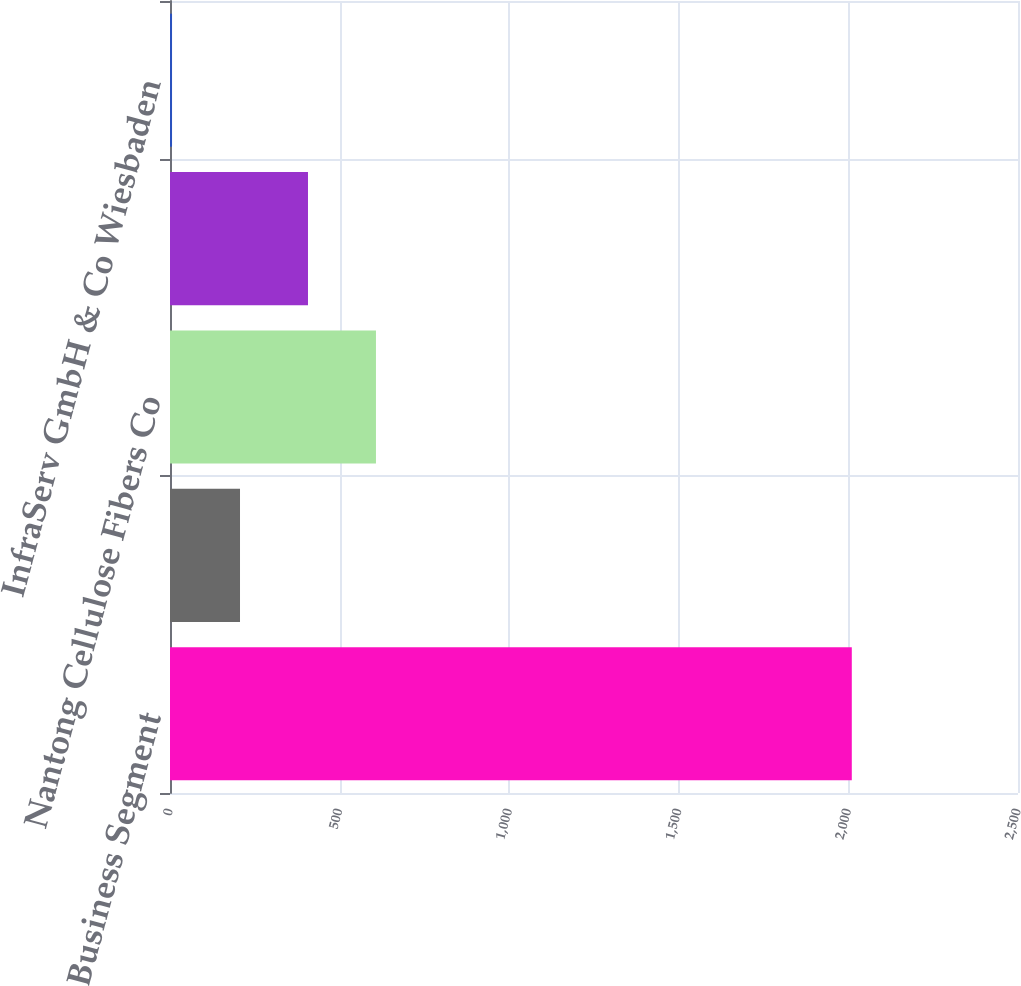Convert chart. <chart><loc_0><loc_0><loc_500><loc_500><bar_chart><fcel>Business Segment<fcel>Kunming Cellulose Fibers Co<fcel>Nantong Cellulose Fibers Co<fcel>Zhuhai Cellulose Fibers Co Ltd<fcel>InfraServ GmbH & Co Wiesbaden<nl><fcel>2010<fcel>206.4<fcel>607.2<fcel>406.8<fcel>6<nl></chart> 